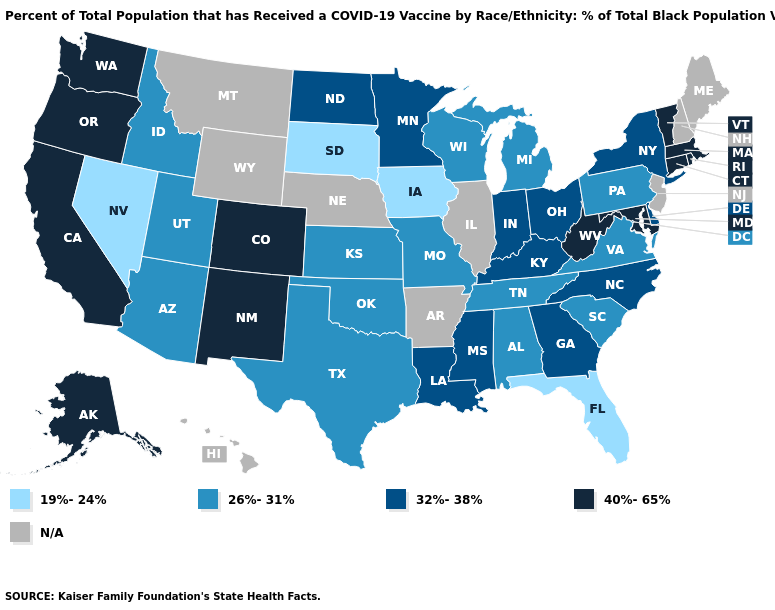What is the value of New Hampshire?
Write a very short answer. N/A. What is the value of Pennsylvania?
Give a very brief answer. 26%-31%. Name the states that have a value in the range 26%-31%?
Be succinct. Alabama, Arizona, Idaho, Kansas, Michigan, Missouri, Oklahoma, Pennsylvania, South Carolina, Tennessee, Texas, Utah, Virginia, Wisconsin. What is the value of Alaska?
Quick response, please. 40%-65%. Which states hav the highest value in the West?
Give a very brief answer. Alaska, California, Colorado, New Mexico, Oregon, Washington. Name the states that have a value in the range N/A?
Quick response, please. Arkansas, Hawaii, Illinois, Maine, Montana, Nebraska, New Hampshire, New Jersey, Wyoming. Which states have the lowest value in the MidWest?
Short answer required. Iowa, South Dakota. Does the first symbol in the legend represent the smallest category?
Write a very short answer. Yes. Does Pennsylvania have the lowest value in the Northeast?
Write a very short answer. Yes. Name the states that have a value in the range N/A?
Be succinct. Arkansas, Hawaii, Illinois, Maine, Montana, Nebraska, New Hampshire, New Jersey, Wyoming. Does Oregon have the highest value in the USA?
Quick response, please. Yes. What is the value of Minnesota?
Write a very short answer. 32%-38%. Name the states that have a value in the range 32%-38%?
Keep it brief. Delaware, Georgia, Indiana, Kentucky, Louisiana, Minnesota, Mississippi, New York, North Carolina, North Dakota, Ohio. Name the states that have a value in the range 40%-65%?
Be succinct. Alaska, California, Colorado, Connecticut, Maryland, Massachusetts, New Mexico, Oregon, Rhode Island, Vermont, Washington, West Virginia. 